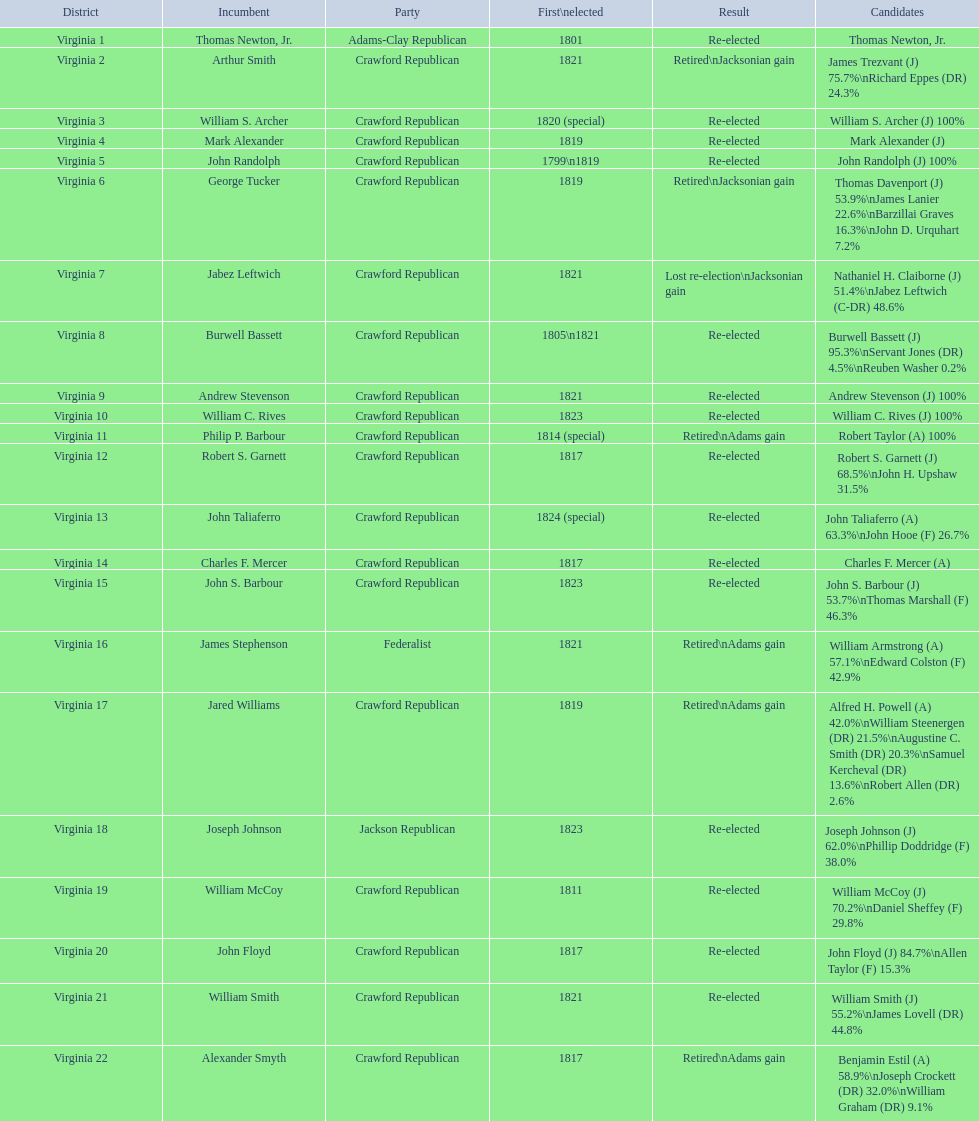Who were the incumbents that were part of the crawford republican party? Arthur Smith, William S. Archer, Mark Alexander, John Randolph, George Tucker, Jabez Leftwich, Burwell Bassett, Andrew Stevenson, William C. Rives, Philip P. Barbour, Robert S. Garnett, John Taliaferro, Charles F. Mercer, John S. Barbour, Jared Williams, William McCoy, John Floyd, William Smith, Alexander Smyth. Which ones were initially elected in 1821? Arthur Smith, Jabez Leftwich, Andrew Stevenson, William Smith. Are there any incumbents with the surname smith? Arthur Smith, William Smith. Out of these two, who didn't succeed in being re-elected? Arthur Smith. 